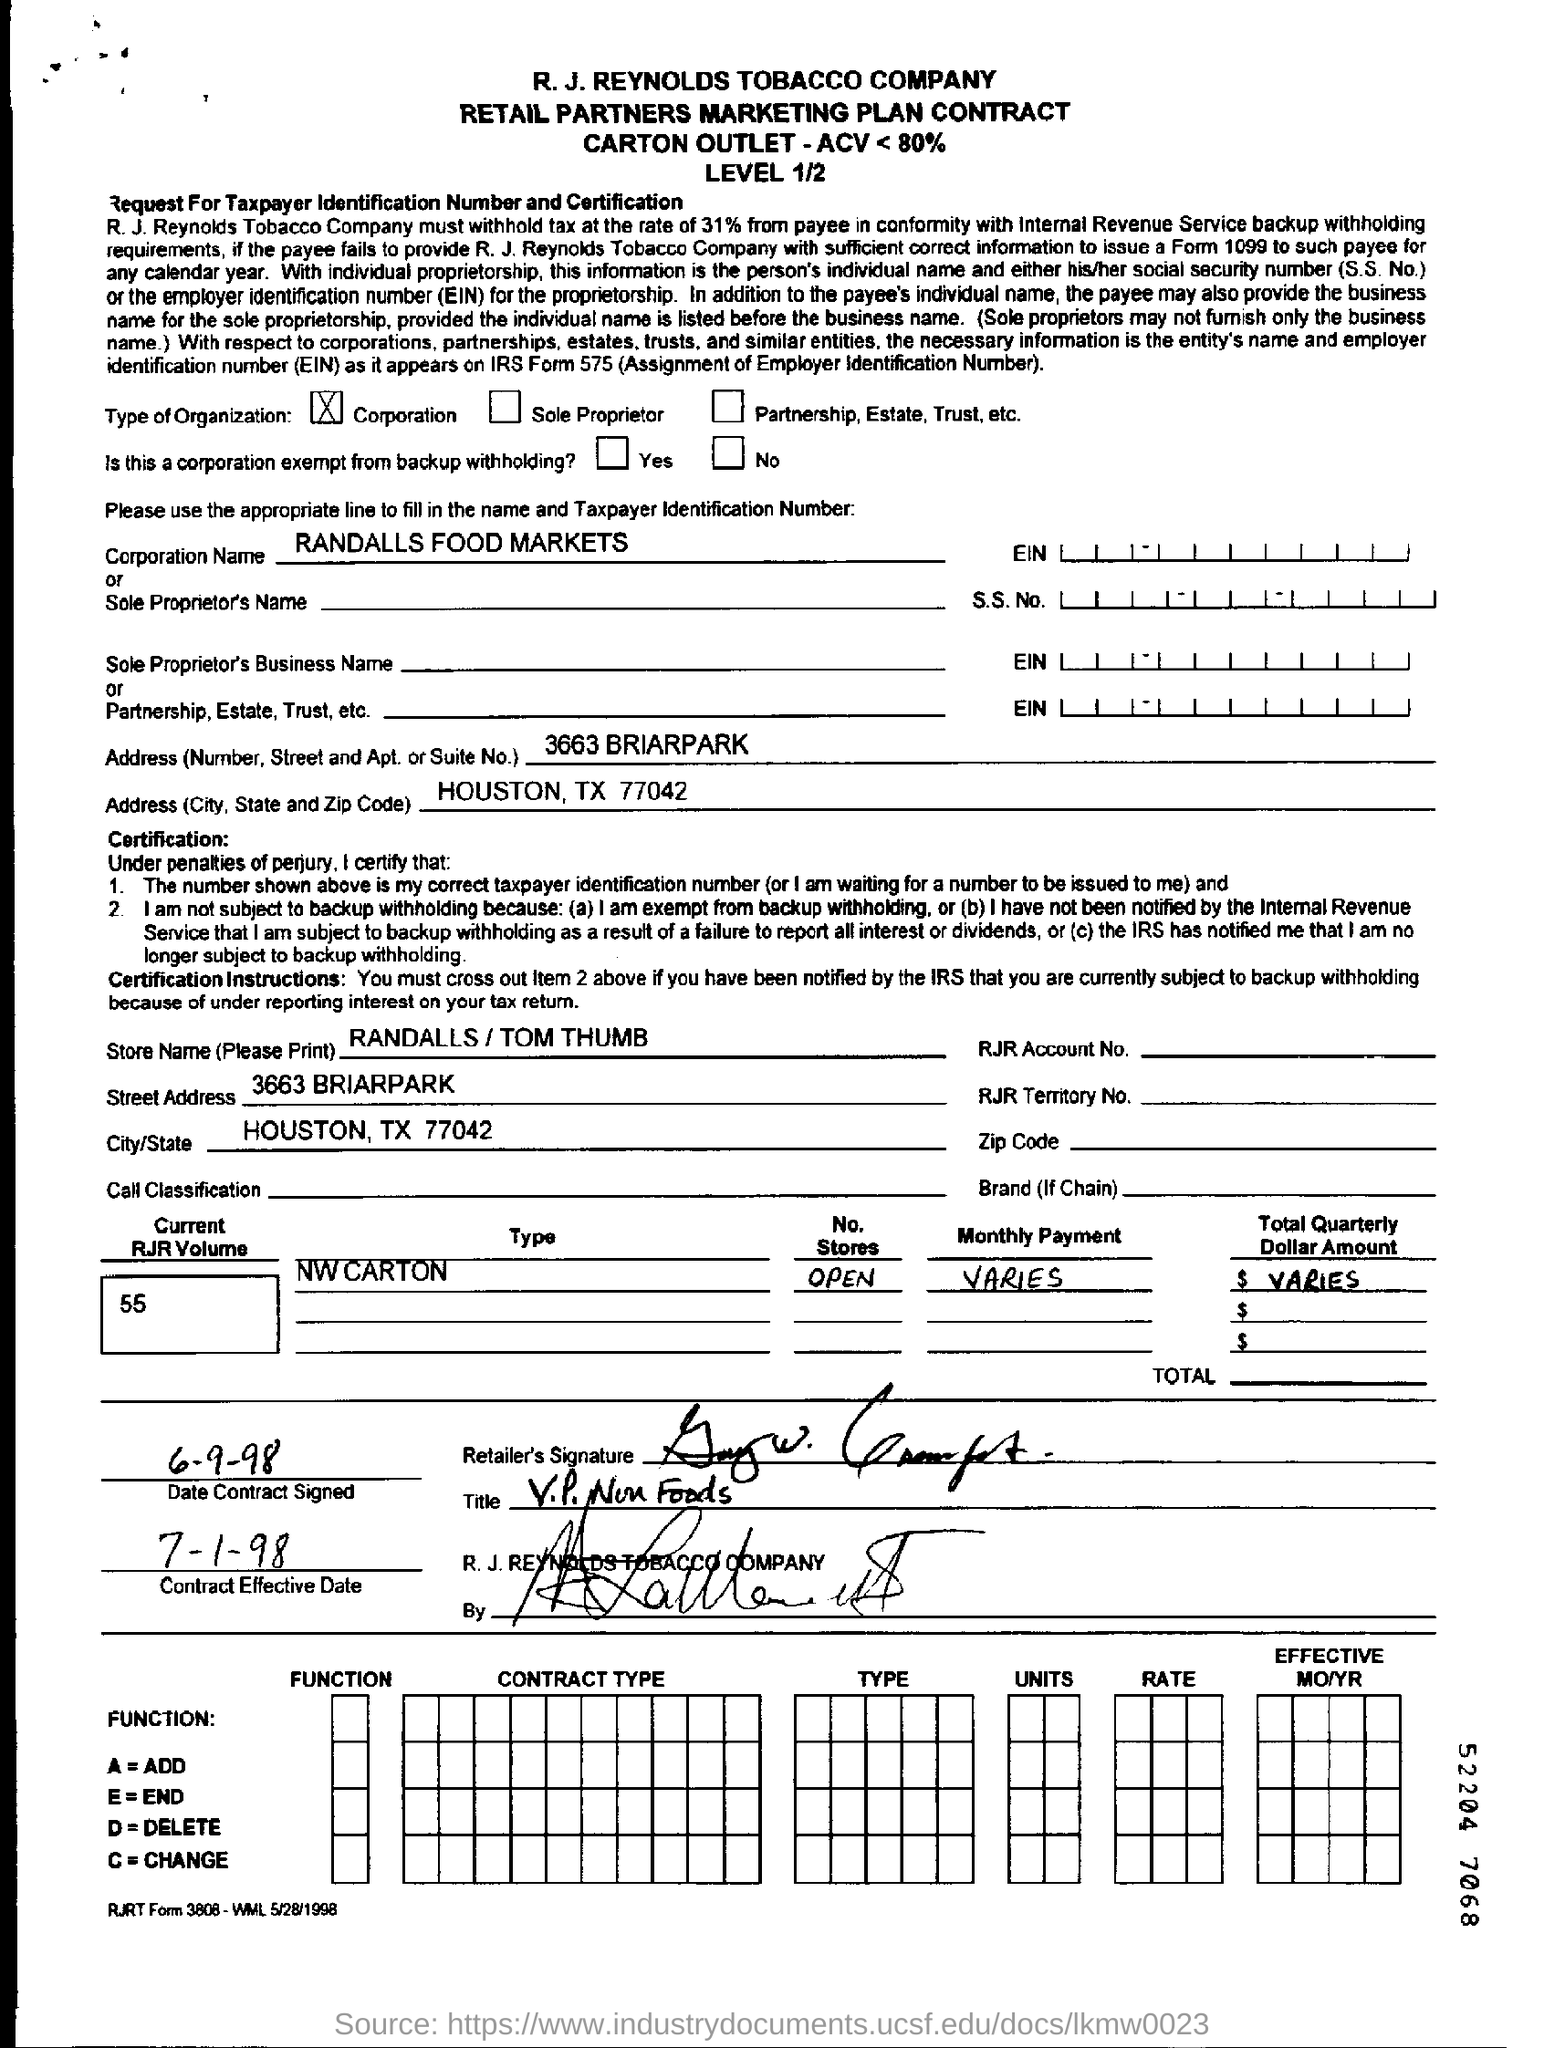List a handful of essential elements in this visual. The current volume of RJR is 55.. Randalls Food Markets Corporation is located in Houston, Texas, with a corporate address at 77042. The Contract Effective Date is July 1, 1998. The corporation named RANDALLS FOOD MARKETS... The contract signing date is September 6, 1998. 